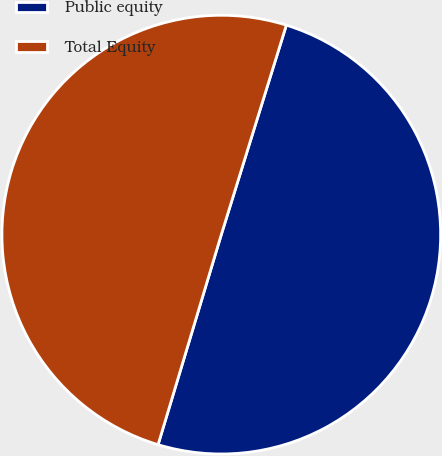<chart> <loc_0><loc_0><loc_500><loc_500><pie_chart><fcel>Public equity<fcel>Total Equity<nl><fcel>49.86%<fcel>50.14%<nl></chart> 